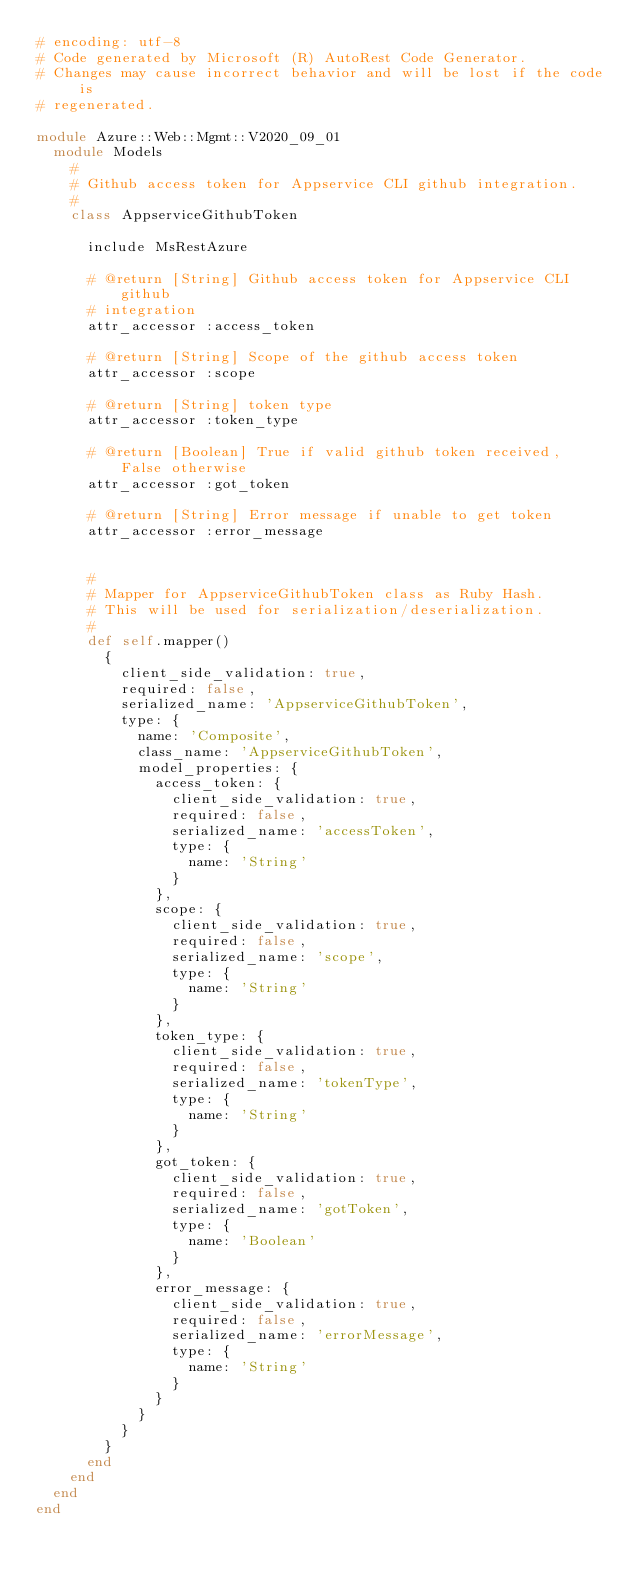Convert code to text. <code><loc_0><loc_0><loc_500><loc_500><_Ruby_># encoding: utf-8
# Code generated by Microsoft (R) AutoRest Code Generator.
# Changes may cause incorrect behavior and will be lost if the code is
# regenerated.

module Azure::Web::Mgmt::V2020_09_01
  module Models
    #
    # Github access token for Appservice CLI github integration.
    #
    class AppserviceGithubToken

      include MsRestAzure

      # @return [String] Github access token for Appservice CLI github
      # integration
      attr_accessor :access_token

      # @return [String] Scope of the github access token
      attr_accessor :scope

      # @return [String] token type
      attr_accessor :token_type

      # @return [Boolean] True if valid github token received, False otherwise
      attr_accessor :got_token

      # @return [String] Error message if unable to get token
      attr_accessor :error_message


      #
      # Mapper for AppserviceGithubToken class as Ruby Hash.
      # This will be used for serialization/deserialization.
      #
      def self.mapper()
        {
          client_side_validation: true,
          required: false,
          serialized_name: 'AppserviceGithubToken',
          type: {
            name: 'Composite',
            class_name: 'AppserviceGithubToken',
            model_properties: {
              access_token: {
                client_side_validation: true,
                required: false,
                serialized_name: 'accessToken',
                type: {
                  name: 'String'
                }
              },
              scope: {
                client_side_validation: true,
                required: false,
                serialized_name: 'scope',
                type: {
                  name: 'String'
                }
              },
              token_type: {
                client_side_validation: true,
                required: false,
                serialized_name: 'tokenType',
                type: {
                  name: 'String'
                }
              },
              got_token: {
                client_side_validation: true,
                required: false,
                serialized_name: 'gotToken',
                type: {
                  name: 'Boolean'
                }
              },
              error_message: {
                client_side_validation: true,
                required: false,
                serialized_name: 'errorMessage',
                type: {
                  name: 'String'
                }
              }
            }
          }
        }
      end
    end
  end
end
</code> 